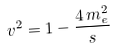<formula> <loc_0><loc_0><loc_500><loc_500>v ^ { 2 } = 1 - \frac { 4 \, m _ { e } ^ { 2 } } { s }</formula> 